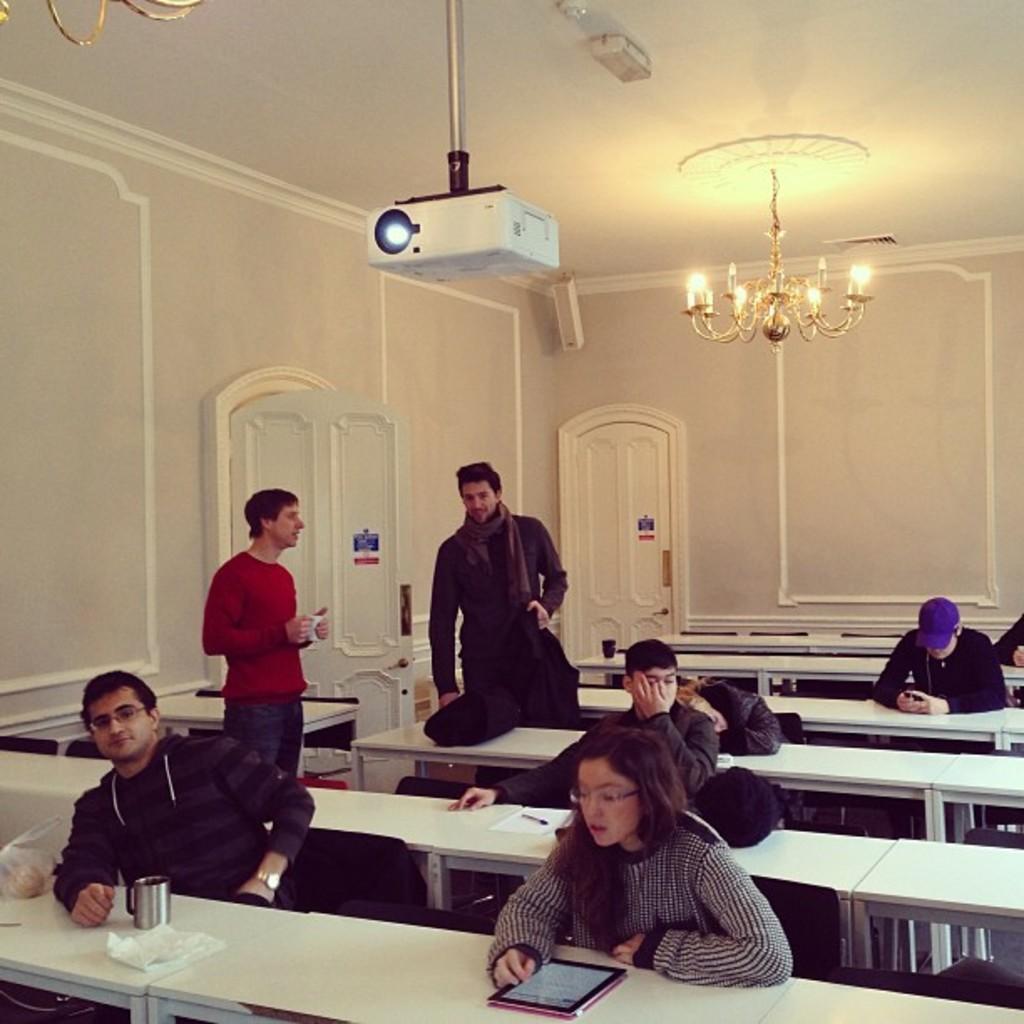Could you give a brief overview of what you see in this image? In the image we can see there are people who are sititng on the chair infront of them there is a table and the two men are over here standing and on the top there is a projector and at the back there is a chandelier. 